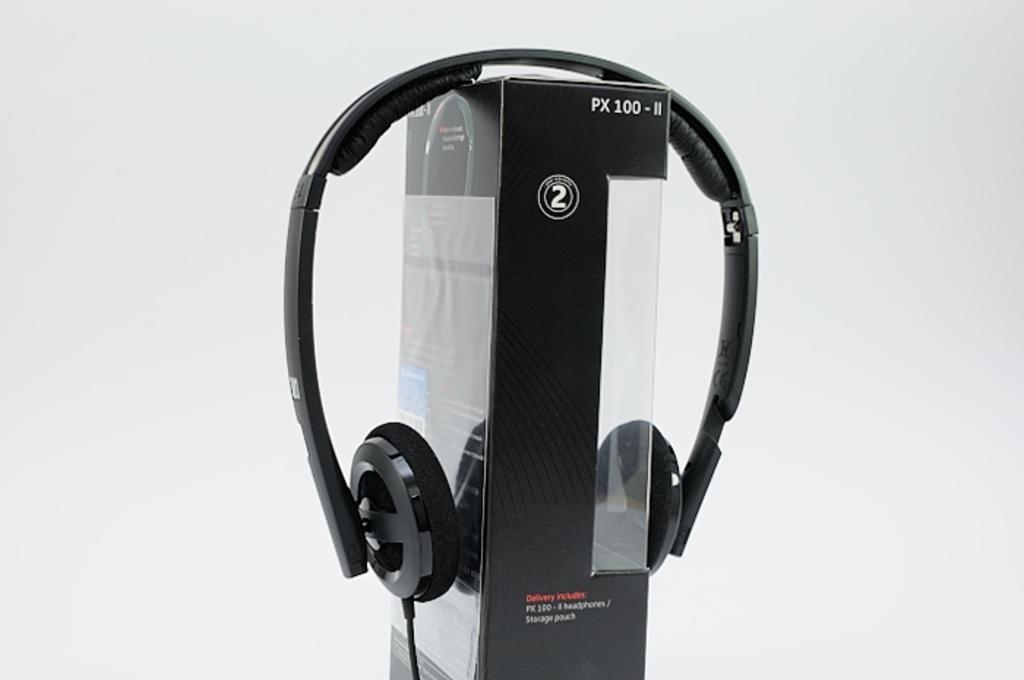How would you summarize this image in a sentence or two? This image consists of headphones and a box in the middle. They are in black color. 